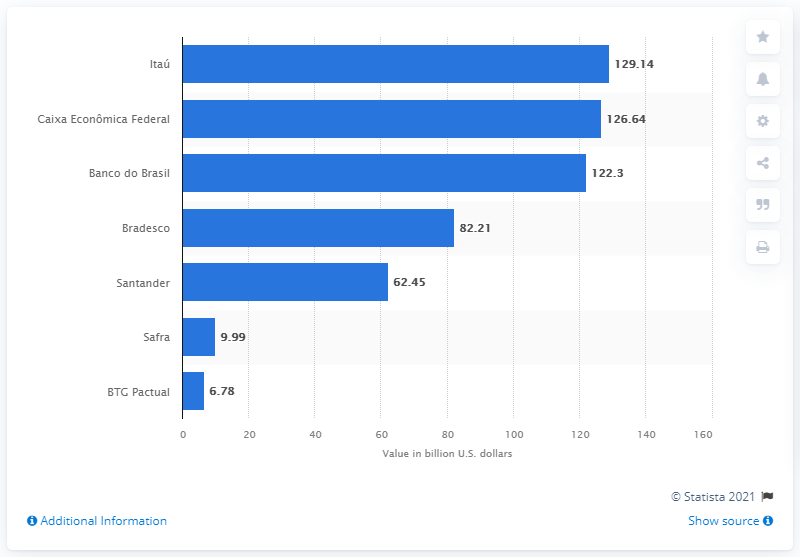What is the ranking of banks by deposit value according to this image? The ranking of banks by deposit value from highest to lowest in this image is as follows: Itaú, Caixa Econômica Federal, Banco do Brasil, Bradesco, Santander, Safra, and BTC Pactual. 